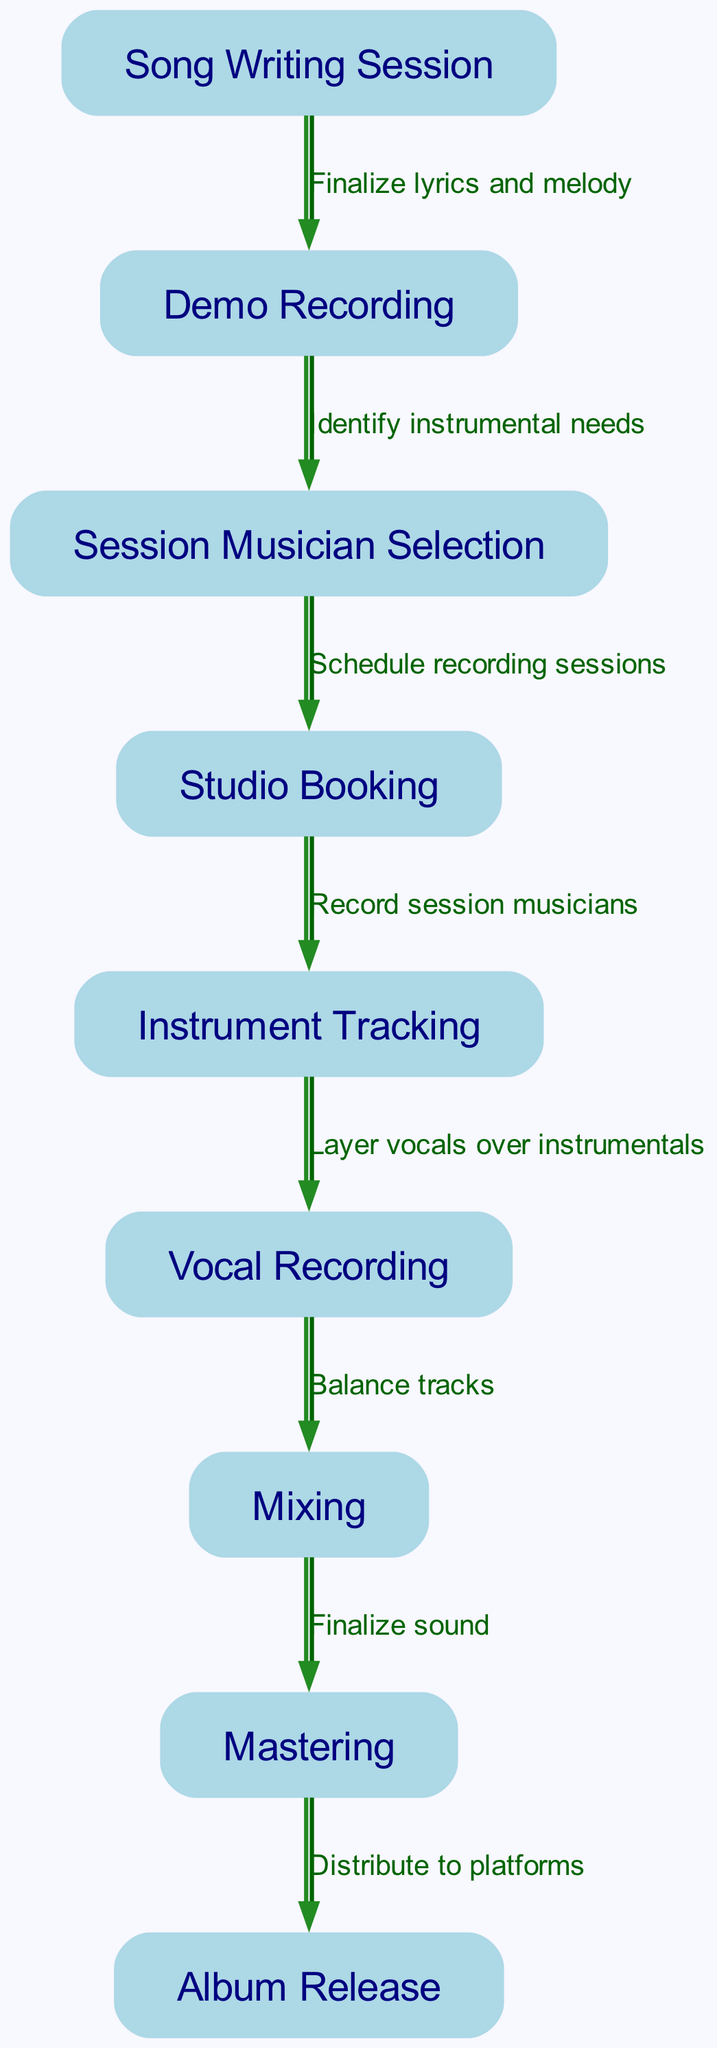What is the first step in the workflow? The first step listed in the diagram is the "Song Writing Session." This is indicated as the starting node, from which other steps are connected.
Answer: Song Writing Session How many total nodes are in the diagram? By counting the distinct nodes labeled in the diagram, there are a total of nine nodes. Each node represents a different stage in the workflow.
Answer: 9 What follows after Demo Recording? The edge leading from "Demo Recording" points to "Session Musician Selection," indicating the next step after demo recording in the workflow.
Answer: Session Musician Selection Which node is directly before Mixing? The edge leading into "Mixing" comes from "Vocal Recording," which indicates that the vocals are layered over instrumentals right before the mixing process.
Answer: Vocal Recording What is the final step in the workflow? The last node in the sequence is "Album Release," which is the outcome after the mastering step is completed.
Answer: Album Release Which node is indicated as having an instrumental focus? The node "Instrument Tracking" is specifically focused on recording the contributions of session musicians, emphasizing the instrumental aspect of the album production.
Answer: Instrument Tracking What is required to move from Song Writing Session to Demo Recording? The transition from "Song Writing Session" to "Demo Recording" requires finalizing lyrics and melody, as indicated by the label on the edge between these two nodes.
Answer: Finalize lyrics and melody What process follows after Mastering? The step that follows "Mastering" is "Album Release," which signifies the final distribution of the album to various platforms.
Answer: Album Release 